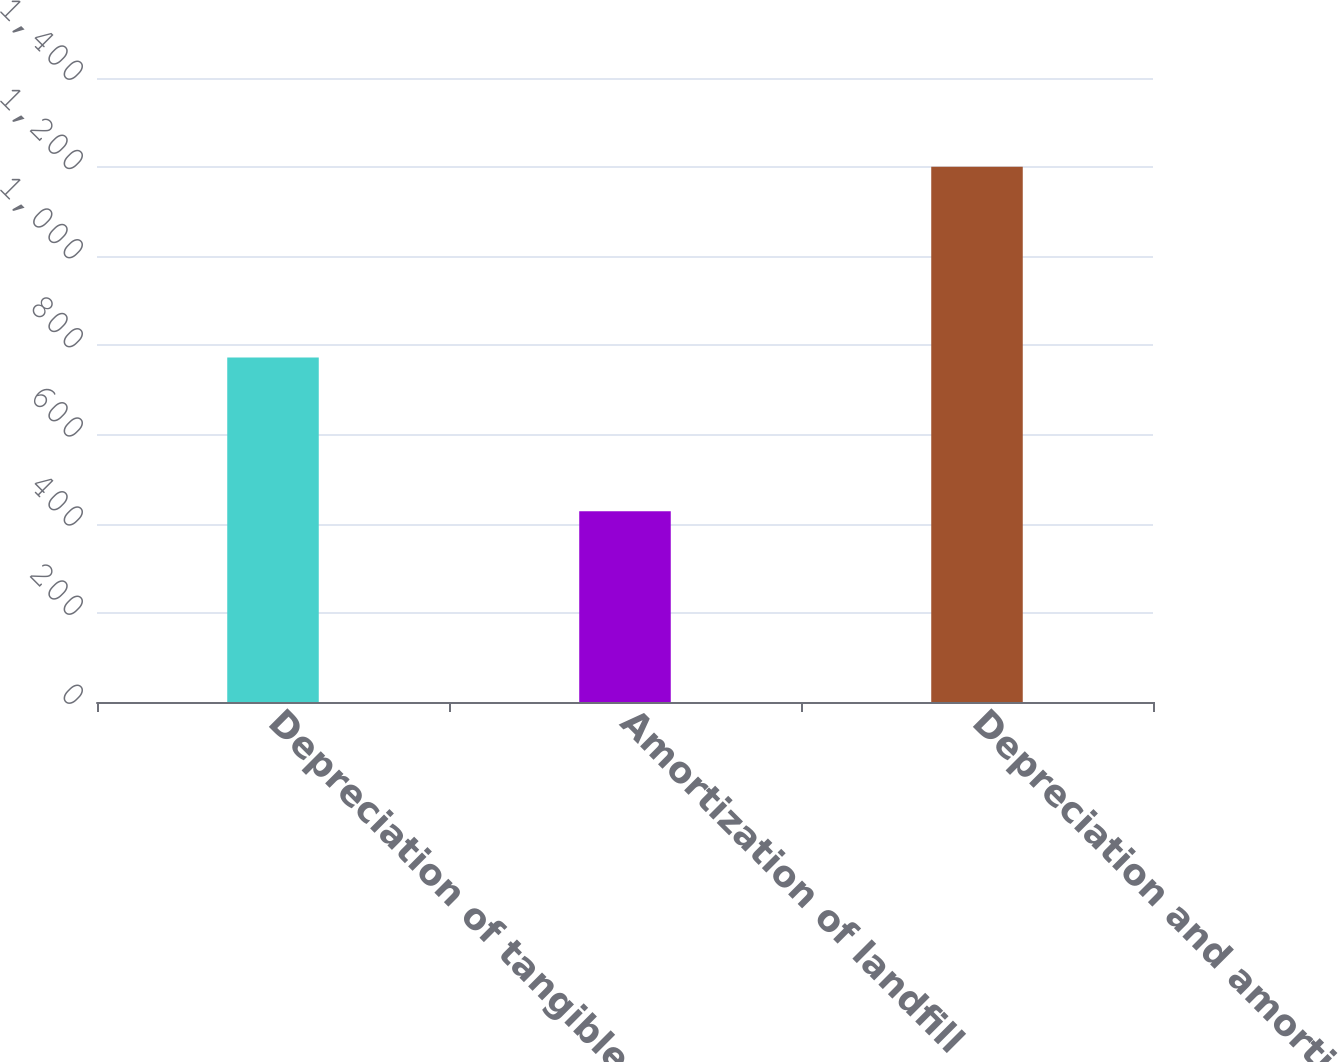Convert chart. <chart><loc_0><loc_0><loc_500><loc_500><bar_chart><fcel>Depreciation of tangible<fcel>Amortization of landfill<fcel>Depreciation and amortization<nl><fcel>773<fcel>428<fcel>1201<nl></chart> 